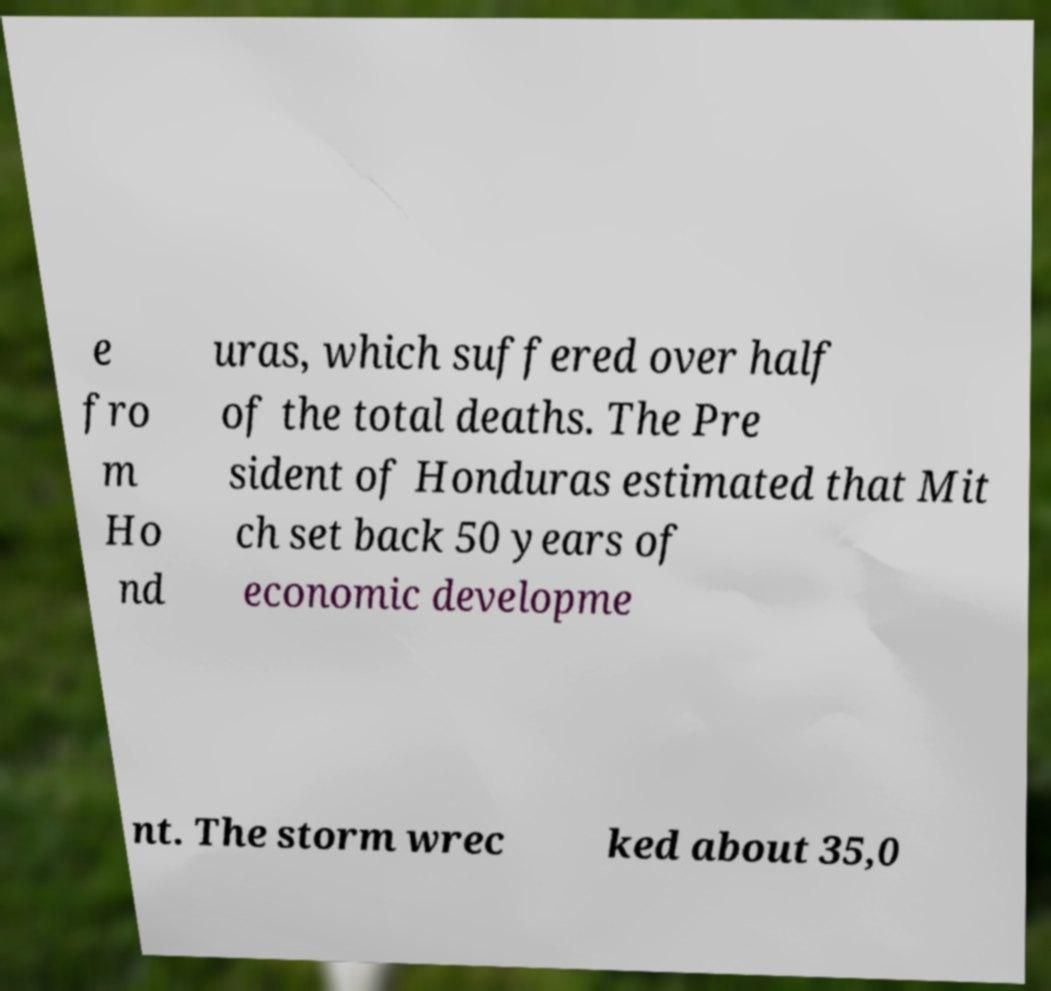Can you read and provide the text displayed in the image?This photo seems to have some interesting text. Can you extract and type it out for me? e fro m Ho nd uras, which suffered over half of the total deaths. The Pre sident of Honduras estimated that Mit ch set back 50 years of economic developme nt. The storm wrec ked about 35,0 